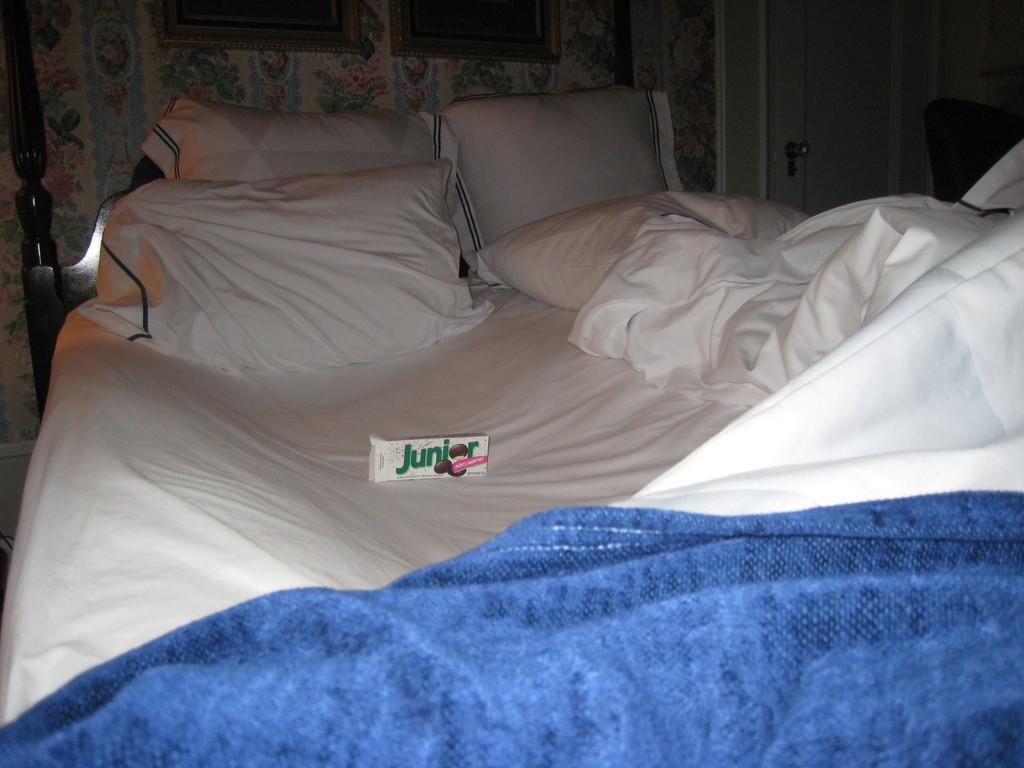What type of furniture is present in the image? There is a bed in the image. What is placed on the bed? There are two pillows and boxes labeled "junior" on the bed. What is covering the bed? There is a bed sheet on the bed. What can be seen on the wall behind the bed? There are photo frames on the wall. What type of sticks are used to create the place in the image? There are no sticks present in the image, and the image does not depict a place. 